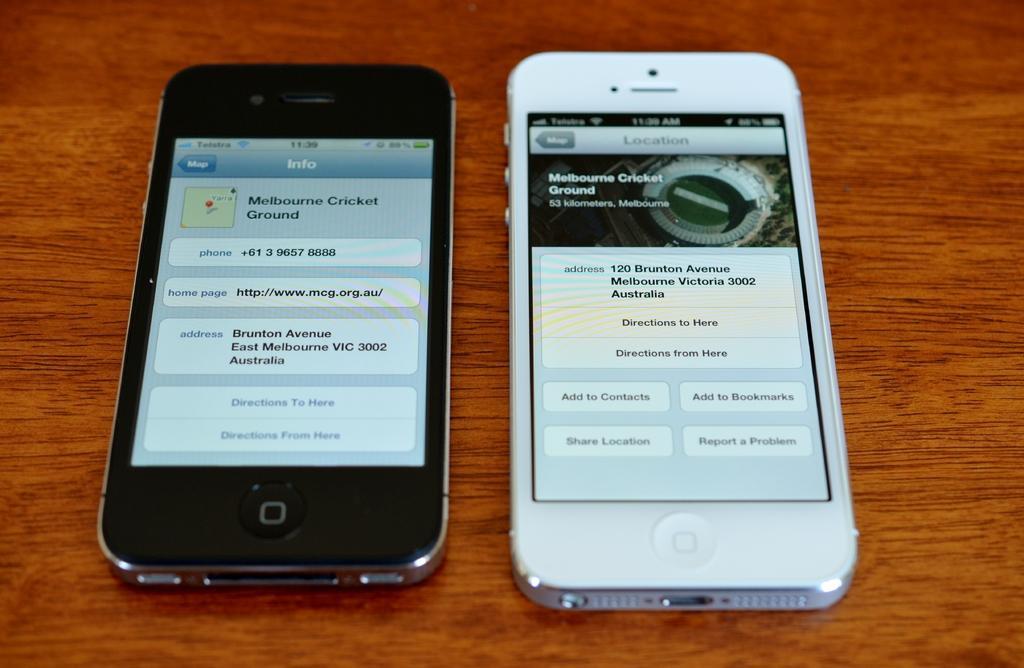How would you summarize this image in a sentence or two? In the image we can see a table, on the table we can see two mobile phones. 